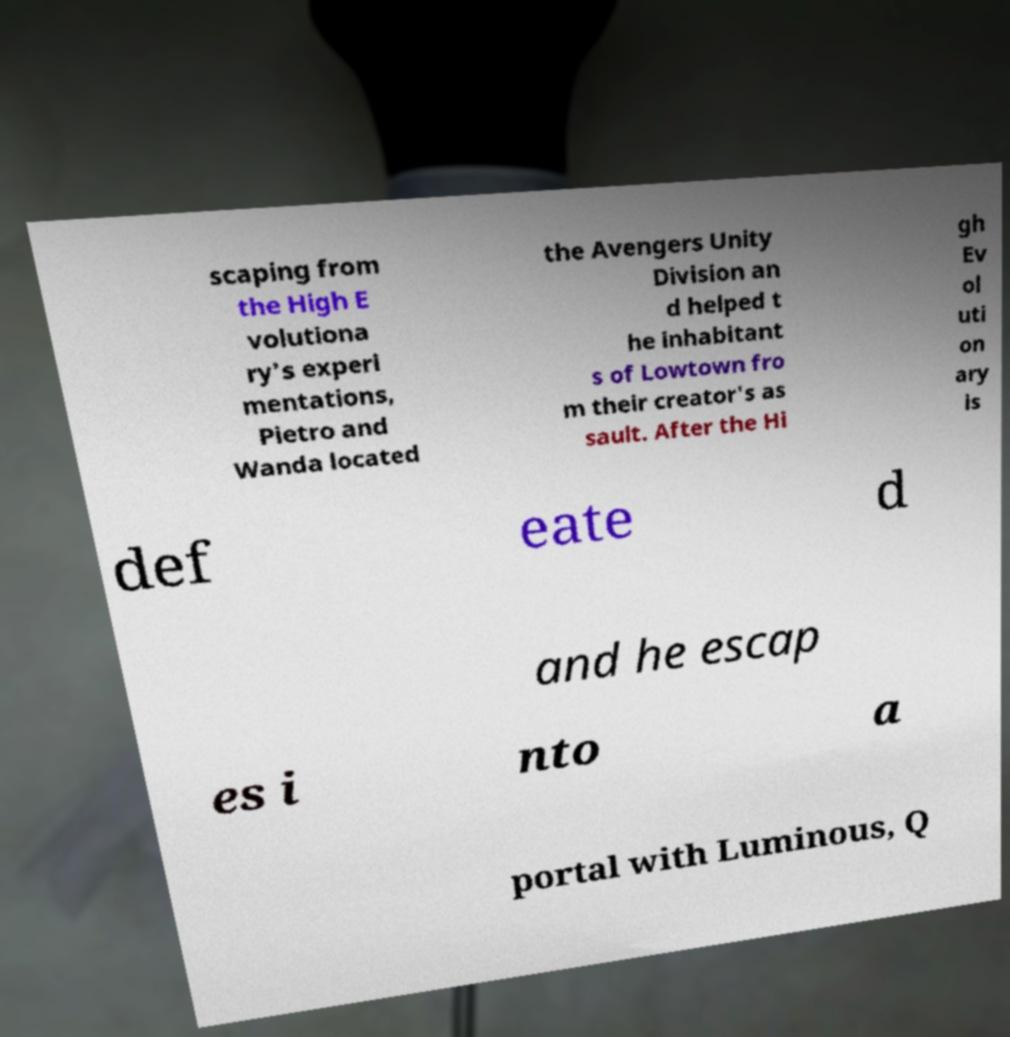Can you accurately transcribe the text from the provided image for me? scaping from the High E volutiona ry's experi mentations, Pietro and Wanda located the Avengers Unity Division an d helped t he inhabitant s of Lowtown fro m their creator's as sault. After the Hi gh Ev ol uti on ary is def eate d and he escap es i nto a portal with Luminous, Q 